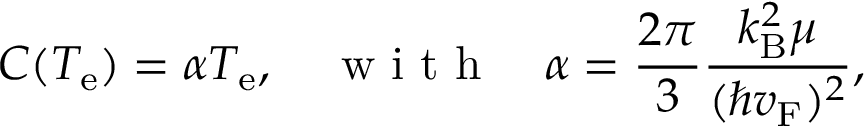<formula> <loc_0><loc_0><loc_500><loc_500>C ( T _ { e } ) = \alpha T _ { e } , w i t h \alpha = \frac { 2 \pi } { 3 } \frac { k _ { B } ^ { 2 } \mu } { ( \hbar { v } _ { F } ) ^ { 2 } } ,</formula> 